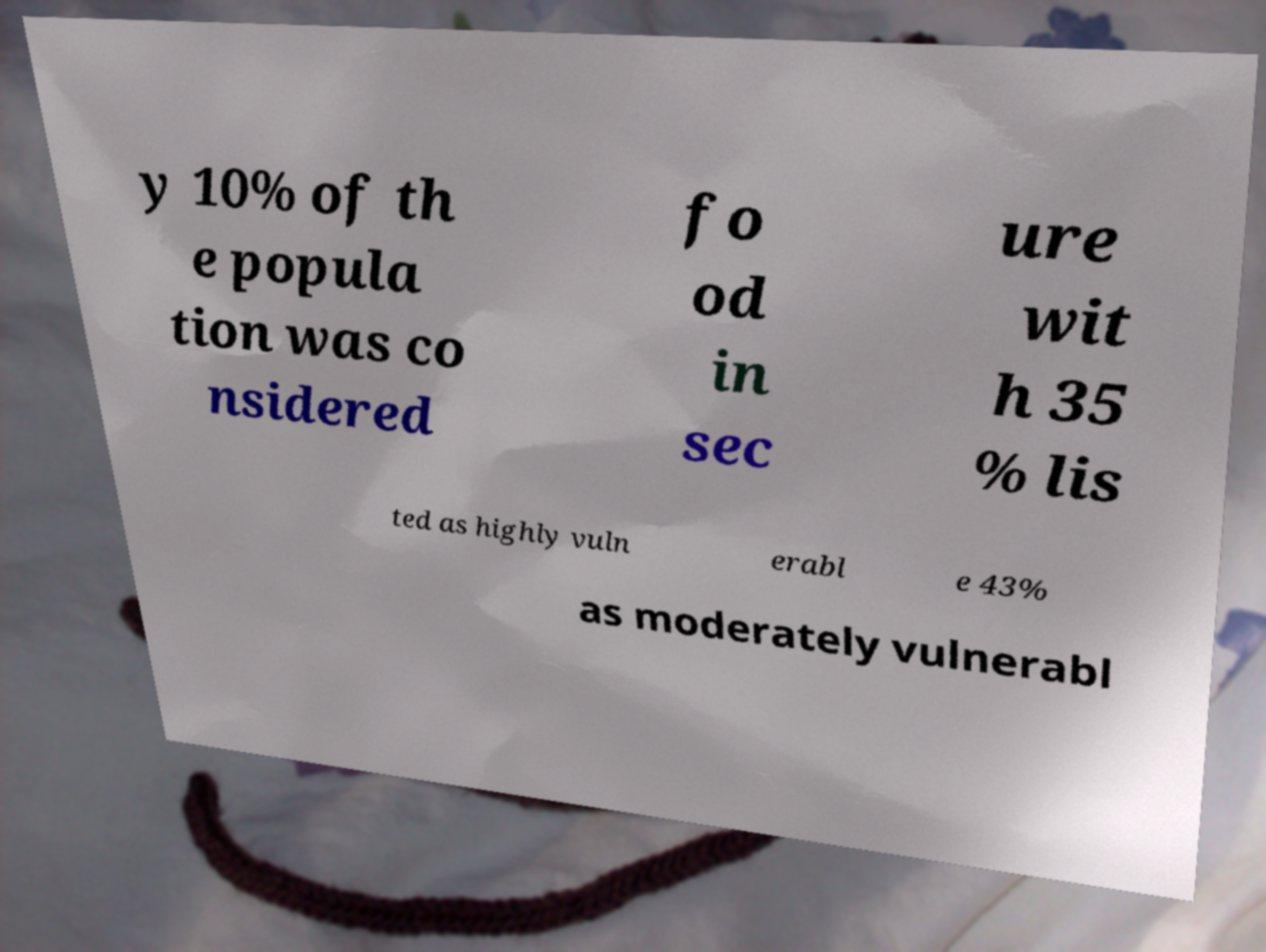Please identify and transcribe the text found in this image. y 10% of th e popula tion was co nsidered fo od in sec ure wit h 35 % lis ted as highly vuln erabl e 43% as moderately vulnerabl 